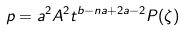Convert formula to latex. <formula><loc_0><loc_0><loc_500><loc_500>p = a ^ { 2 } A ^ { 2 } t ^ { b - n a + 2 a - 2 } P ( \zeta )</formula> 